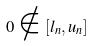<formula> <loc_0><loc_0><loc_500><loc_500>0 \notin [ l _ { n } , u _ { n } ]</formula> 